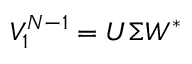<formula> <loc_0><loc_0><loc_500><loc_500>V _ { 1 } ^ { N - 1 } = U \Sigma W ^ { * }</formula> 